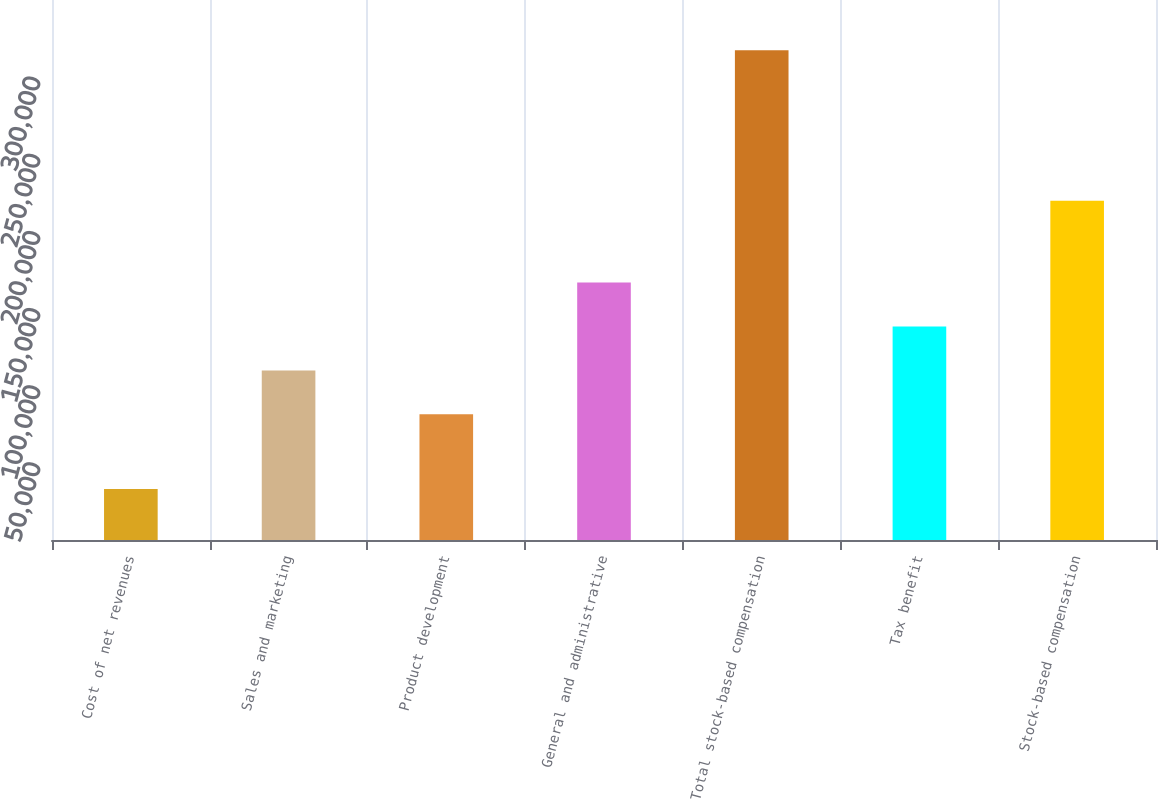Convert chart. <chart><loc_0><loc_0><loc_500><loc_500><bar_chart><fcel>Cost of net revenues<fcel>Sales and marketing<fcel>Product development<fcel>General and administrative<fcel>Total stock-based compensation<fcel>Tax benefit<fcel>Stock-based compensation<nl><fcel>32981<fcel>109932<fcel>81489<fcel>166818<fcel>317410<fcel>138375<fcel>219838<nl></chart> 